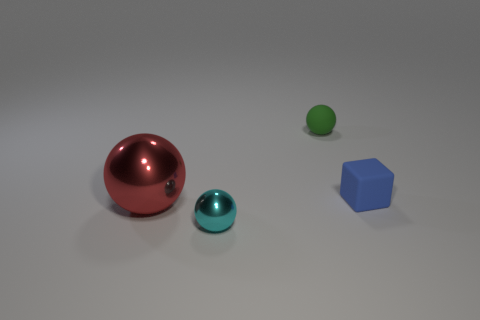What color is the thing that is behind the small rubber block that is to the right of the big red thing?
Give a very brief answer. Green. Is the number of big metal things less than the number of big gray rubber blocks?
Your answer should be very brief. No. Is there a large object made of the same material as the small cyan thing?
Make the answer very short. Yes. There is a tiny green rubber thing; is its shape the same as the cyan metal object that is in front of the green sphere?
Offer a very short reply. Yes. There is a red shiny thing; are there any small spheres in front of it?
Make the answer very short. Yes. What number of large red metal things have the same shape as the green matte object?
Provide a succinct answer. 1. Do the blue cube and the object that is behind the blue rubber object have the same material?
Your response must be concise. Yes. How many small green balls are there?
Your answer should be very brief. 1. There is a sphere behind the blue block; what size is it?
Offer a very short reply. Small. How many blue matte blocks are the same size as the cyan object?
Keep it short and to the point. 1. 